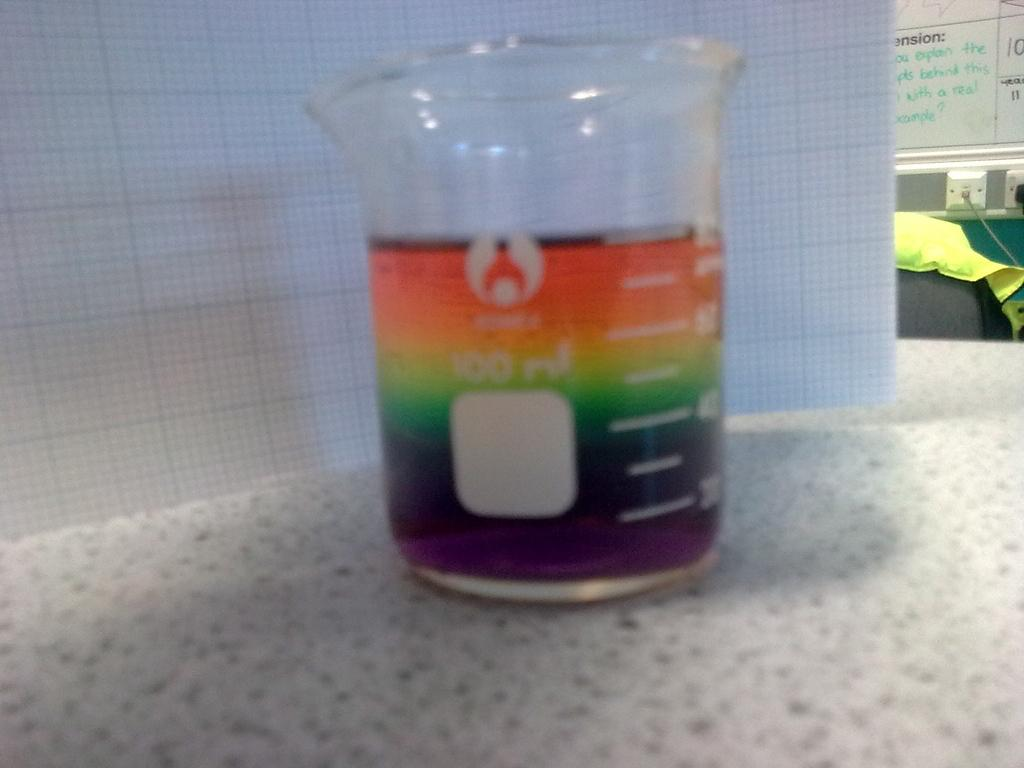<image>
Render a clear and concise summary of the photo. the beaker of rainbow fluid will hold 100 ml 